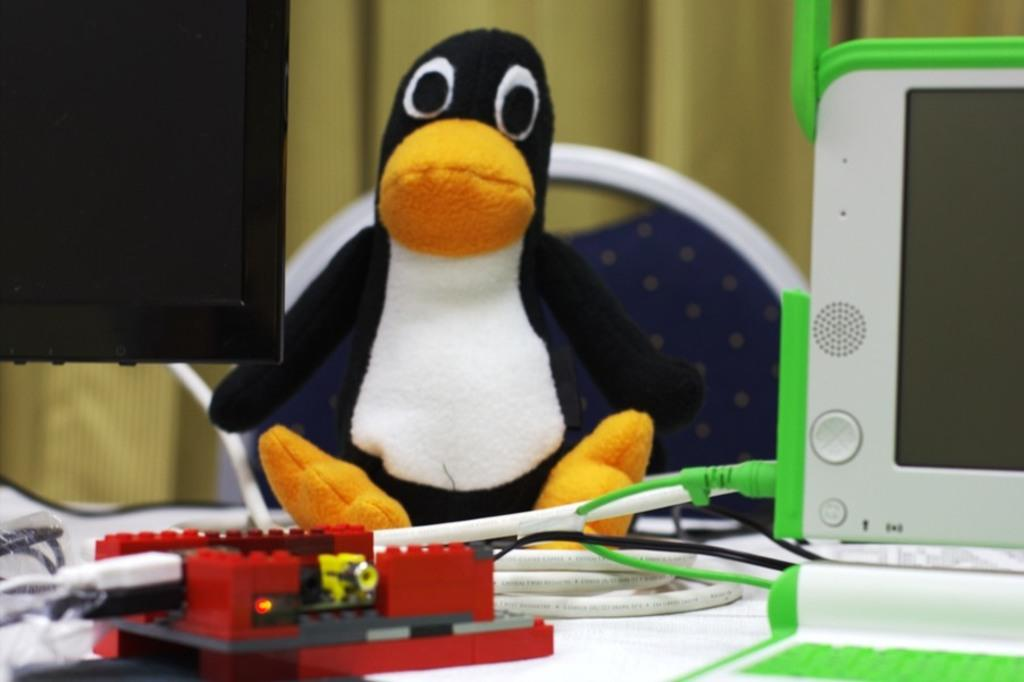What object is on the table in the image? There is a toy on the table in the image. What colors are used for the toy? The toy is in white and black color. What can be seen on the left side of the image? There is a screen on the left side of the image. What type of furniture is in front of the table? There is a chair in front of the table in the image. Can you see the manager sitting on the hill in the image? There is no hill or manager present in the image. What type of heart is visible on the toy in the image? There is no heart depicted on the toy in the image; it is in white and black color. 